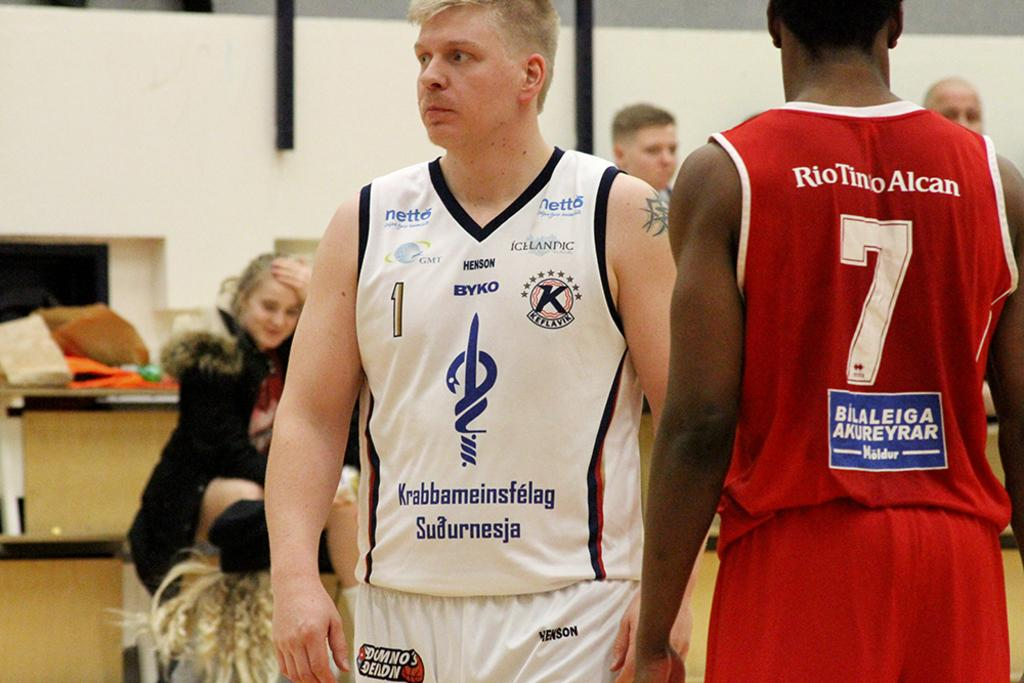<image>
Render a clear and concise summary of the photo. one man in red with the number 7 and another both playing basketball 